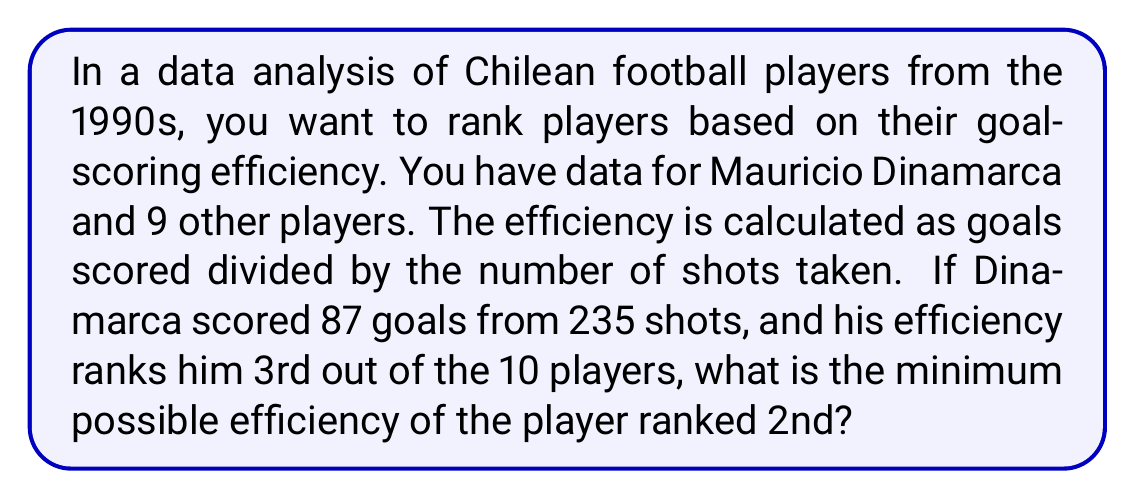Show me your answer to this math problem. To solve this problem, we need to follow these steps:

1. Calculate Dinamarca's efficiency:
   $$\text{Dinamarca's Efficiency} = \frac{\text{Goals}}{\text{Shots}} = \frac{87}{235} \approx 0.3702$$

2. Since Dinamarca is ranked 3rd, there must be two players with higher efficiency.

3. To find the minimum possible efficiency for the 2nd ranked player, we need to consider the case where the 1st and 2nd ranked players have efficiencies as close as possible to Dinamarca's, while still being higher.

4. The minimum efficiency for the 2nd ranked player would be just slightly higher than Dinamarca's. We can represent this as:
   $$\text{2nd Player's Efficiency} = \frac{87}{235} + \epsilon$$
   where $\epsilon$ is an infinitesimally small positive number.

5. To express this as a fraction, we need to find the smallest possible increase in goals scored or decrease in shots taken that would result in a higher efficiency than Dinamarca's.

6. The smallest possible increase would be scoring one more goal with the same number of shots:
   $$\text{Minimum 2nd Player's Efficiency} = \frac{88}{235} \approx 0.3744$$

This efficiency is higher than Dinamarca's and represents the minimum possible efficiency for the player ranked 2nd.
Answer: $$\frac{88}{235} \approx 0.3744$$ 